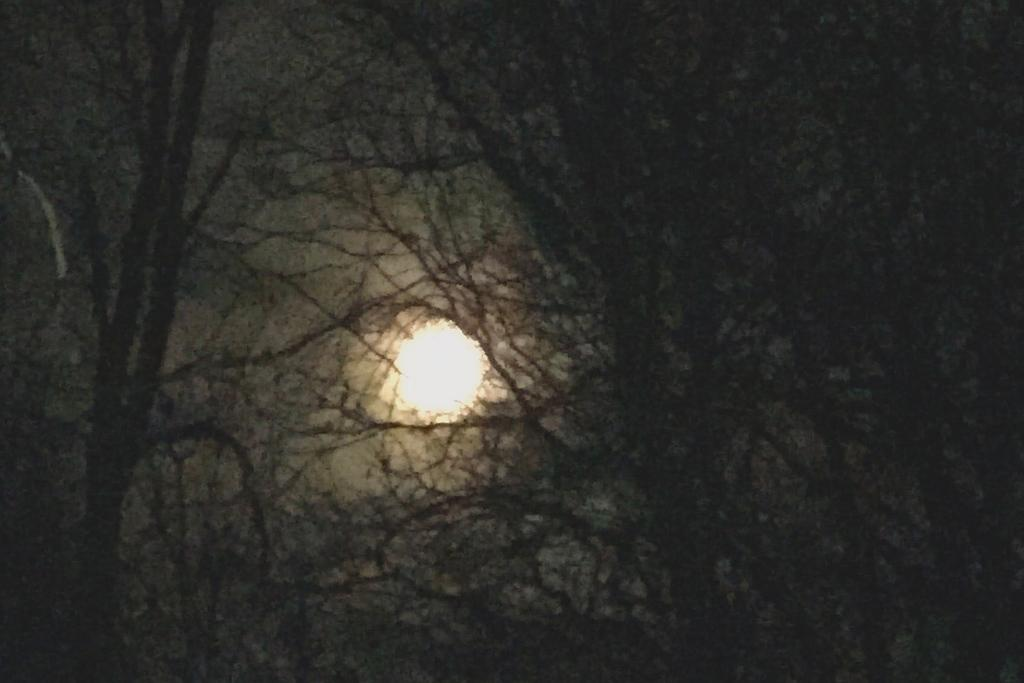What is the lighting condition in the image? The image is taken during a dark time. What type of natural elements can be seen in the image? There are trees in the image. What celestial body is visible in the image? The moon is visible in the image. What type of silver magic can be seen in the image? There is no silver magic present in the image. The image features trees and the moon during a dark time. 